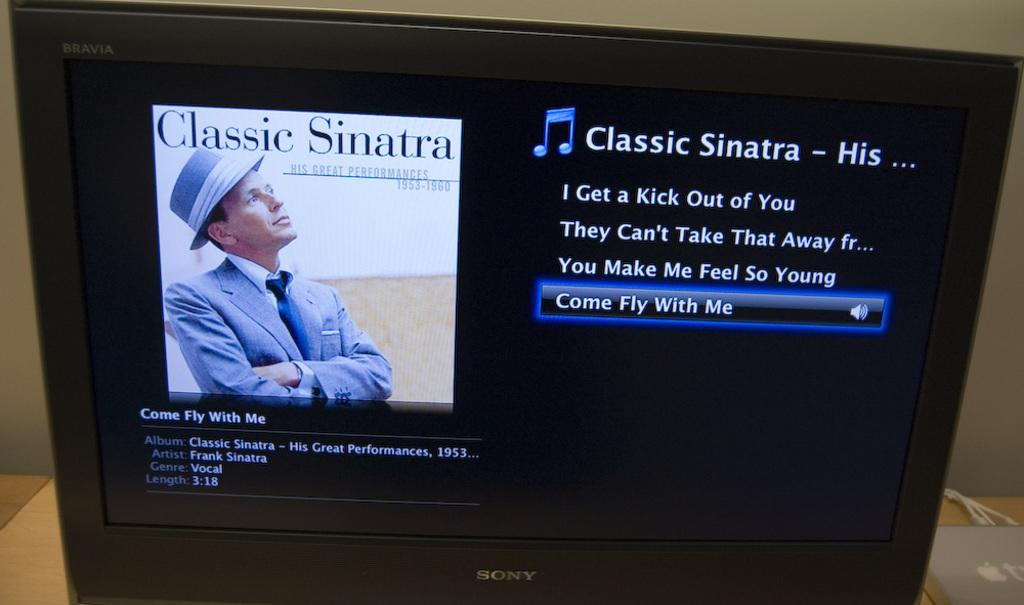<image>
Offer a succinct explanation of the picture presented. Video monitor that has music titled Classic Sinatra featuring four songs. 